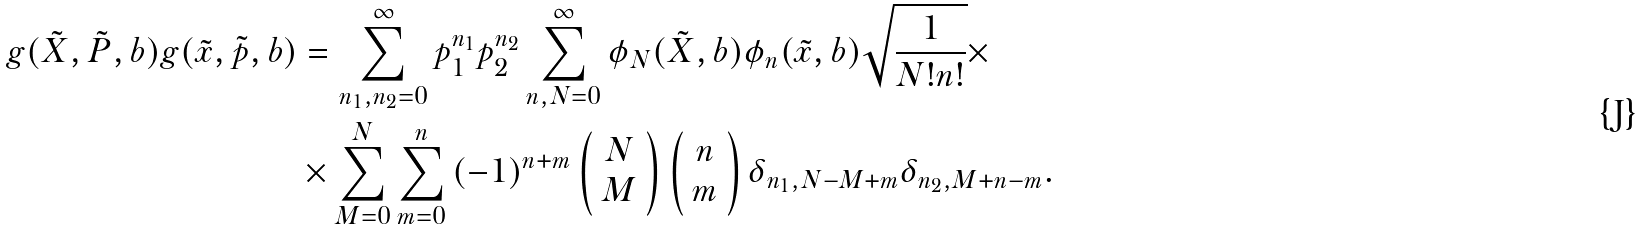<formula> <loc_0><loc_0><loc_500><loc_500>g ( \tilde { X } , \tilde { P } , b ) g ( \tilde { x } , \tilde { p } , b ) & = \sum _ { n _ { 1 } , n _ { 2 } = 0 } ^ { \infty } { p _ { 1 } ^ { n _ { 1 } } p _ { 2 } ^ { n _ { 2 } } } \sum _ { n , N = 0 } ^ { \infty } \phi _ { N } ( \tilde { X } , b ) \phi _ { n } ( \tilde { x } , b ) \sqrt { \frac { 1 } { N ! n ! } } \times \\ & \times \sum _ { M = 0 } ^ { N } \sum _ { m = 0 } ^ { n } { ( - 1 ) ^ { n + m } \left ( \begin{array} { c } N \\ M \end{array} \right ) \left ( \begin{array} { c } n \\ m \end{array} \right ) \delta _ { n _ { 1 } , N - M + m } \delta _ { n _ { 2 } , M + n - m } } .</formula> 